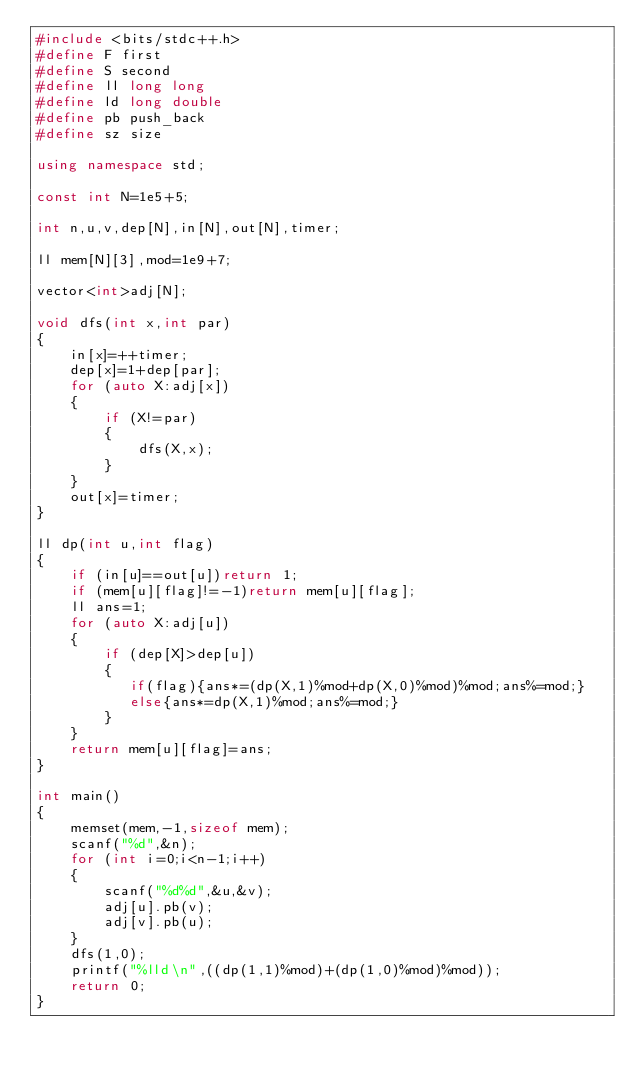Convert code to text. <code><loc_0><loc_0><loc_500><loc_500><_C++_>#include <bits/stdc++.h>
#define F first
#define S second
#define ll long long
#define ld long double
#define pb push_back
#define sz size

using namespace std;

const int N=1e5+5;

int n,u,v,dep[N],in[N],out[N],timer;

ll mem[N][3],mod=1e9+7;

vector<int>adj[N];

void dfs(int x,int par)
{
    in[x]=++timer;
    dep[x]=1+dep[par];
    for (auto X:adj[x])
    {
        if (X!=par)
        {
            dfs(X,x);
        }
    }
    out[x]=timer;
}

ll dp(int u,int flag)
{
    if (in[u]==out[u])return 1;
    if (mem[u][flag]!=-1)return mem[u][flag];
    ll ans=1;
    for (auto X:adj[u])
    {
        if (dep[X]>dep[u])
        {
           if(flag){ans*=(dp(X,1)%mod+dp(X,0)%mod)%mod;ans%=mod;}
           else{ans*=dp(X,1)%mod;ans%=mod;}
        }
    }
    return mem[u][flag]=ans;
}

int main()
{
    memset(mem,-1,sizeof mem);
    scanf("%d",&n);
    for (int i=0;i<n-1;i++)
    {
        scanf("%d%d",&u,&v);
        adj[u].pb(v);
        adj[v].pb(u);
    }
    dfs(1,0);
    printf("%lld\n",((dp(1,1)%mod)+(dp(1,0)%mod)%mod));
    return 0;
}
</code> 